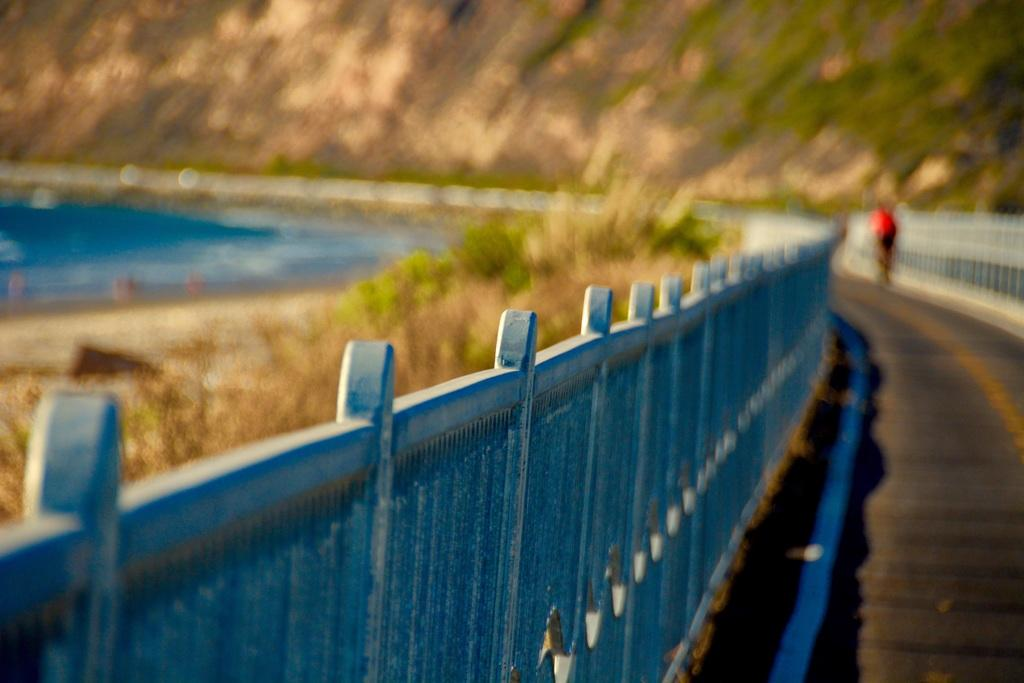What is located on the left side of the image? There is a fence on the left side of the image. What is on the right side of the image? There is a road on the right side of the image. What can be seen in the background of the image? There is water, plants, and a mountain visible in the background of the image. What type of lettuce is growing on the ground in the image? There is no lettuce present in the image; the plants visible in the background are not lettuce. How does the mountain feel about being in the background of the image? The mountain is an inanimate object and does not have feelings, so it cannot feel anything about being in the background of the image. 